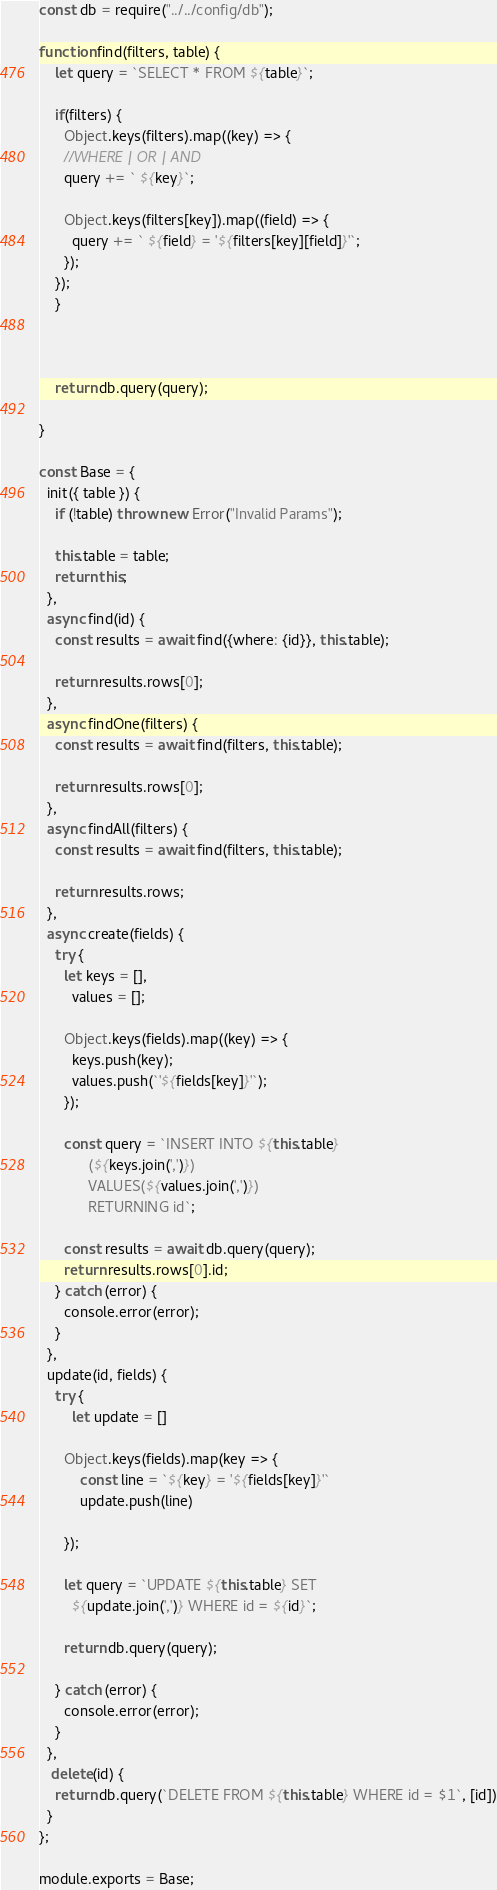<code> <loc_0><loc_0><loc_500><loc_500><_JavaScript_>const db = require("../../config/db");

function find(filters, table) {
    let query = `SELECT * FROM ${table}`;

    if(filters) {
      Object.keys(filters).map((key) => {
      //WHERE | OR | AND
      query += ` ${key}`;

      Object.keys(filters[key]).map((field) => {
        query += ` ${field} = '${filters[key][field]}'`;
      });
    });
    }

    

    return db.query(query);

}

const Base = {
  init({ table }) {
    if (!table) throw new Error("Invalid Params");

    this.table = table;
    return this;
  },
  async find(id) {
    const results = await find({where: {id}}, this.table);

    return results.rows[0];
  },
  async findOne(filters) {
    const results = await find(filters, this.table);

    return results.rows[0];
  },
  async findAll(filters) {
    const results = await find(filters, this.table);

    return results.rows;
  },
  async create(fields) {
    try {
      let keys = [],
        values = [];

      Object.keys(fields).map((key) => {
        keys.push(key);
        values.push(`'${fields[key]}'`);
      });

      const query = `INSERT INTO ${this.table}
            (${keys.join(',')})
            VALUES(${values.join(',')})
            RETURNING id`;

      const results = await db.query(query);
      return results.rows[0].id;
    } catch (error) {
      console.error(error);
    }
  },
  update(id, fields) {
    try {
        let update = []

      Object.keys(fields).map(key => {
          const line = `${key} = '${fields[key]}'`
          update.push(line)

      });

      let query = `UPDATE ${this.table} SET
        ${update.join(',')} WHERE id = ${id}`;

      return db.query(query);

    } catch (error) {
      console.error(error);
    }
  },
   delete(id) {
    return db.query(`DELETE FROM ${this.table} WHERE id = $1`, [id])
  }
};

module.exports = Base;
</code> 